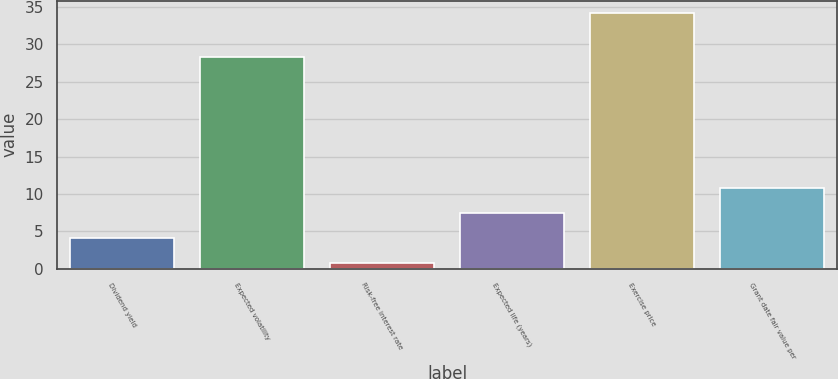Convert chart. <chart><loc_0><loc_0><loc_500><loc_500><bar_chart><fcel>Dividend yield<fcel>Expected volatility<fcel>Risk-free interest rate<fcel>Expected life (years)<fcel>Exercise price<fcel>Grant date fair value per<nl><fcel>4.12<fcel>28.35<fcel>0.78<fcel>7.46<fcel>34.14<fcel>10.8<nl></chart> 